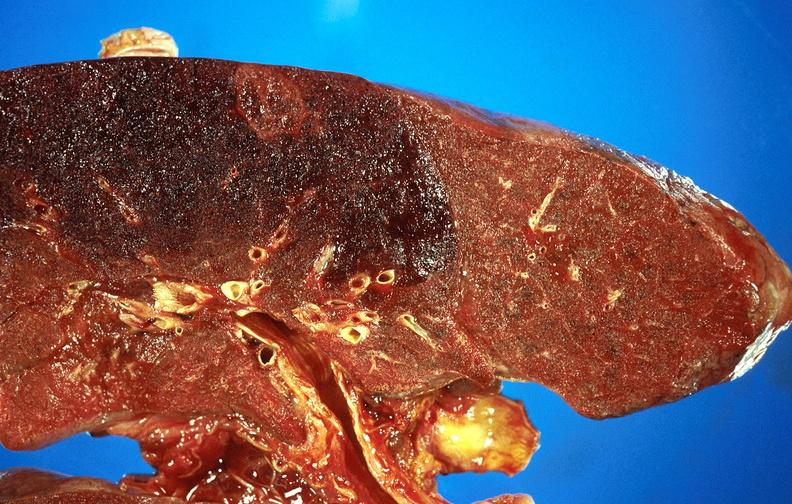how does this image show subacute pulmonary thromboembolus?
Answer the question using a single word or phrase. With acute infarct 